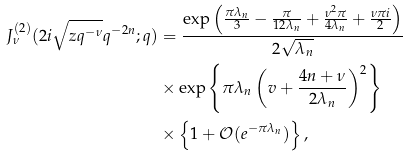Convert formula to latex. <formula><loc_0><loc_0><loc_500><loc_500>J _ { \nu } ^ { ( 2 ) } ( 2 i \sqrt { z q ^ { - \nu } } q ^ { - 2 n } ; q ) & = \frac { \exp \left ( \frac { \pi \lambda _ { n } } { 3 } - \frac { \pi } { 1 2 \lambda _ { n } } + \frac { \nu ^ { 2 } \pi } { 4 \lambda _ { n } } + \frac { \nu \pi i } { 2 } \right ) } { 2 \sqrt { \lambda _ { n } } } \\ & \times \exp \left \{ \pi \lambda _ { n } \left ( v + \frac { 4 n + \nu } { 2 \lambda _ { n } } \right ) ^ { 2 } \right \} \\ & \times \left \{ 1 + \mathcal { O } ( e ^ { - \pi \lambda _ { n } } ) \right \} ,</formula> 